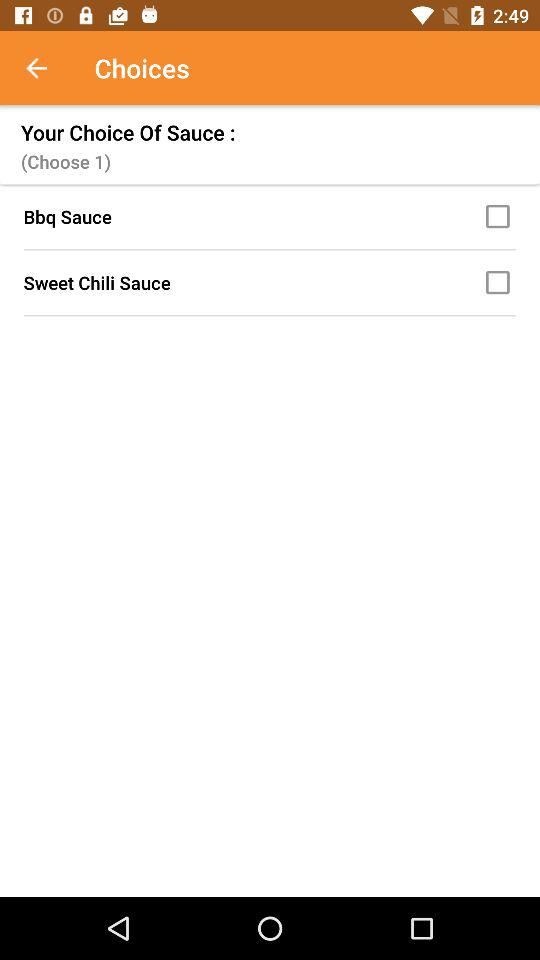How many sauces are available to choose from?
Answer the question using a single word or phrase. 2 